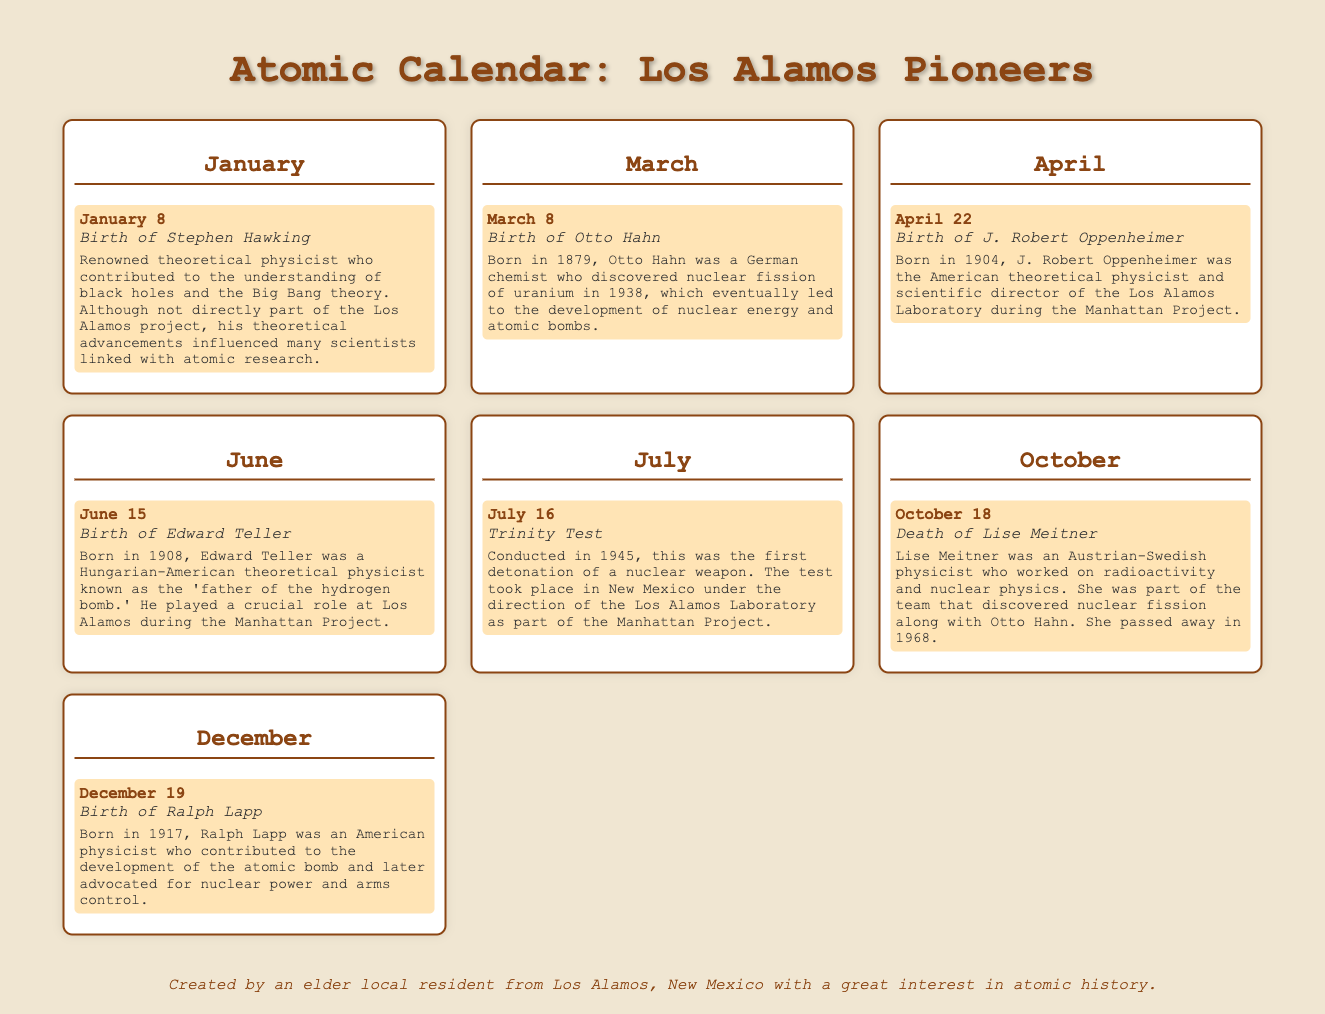what is the birth date of J. Robert Oppenheimer? The birth date of J. Robert Oppenheimer is mentioned in the April section of the document.
Answer: April 22 who is known as the 'father of the hydrogen bomb'? The title 'father of the hydrogen bomb' is given to Edward Teller in the June section of the document.
Answer: Edward Teller when was the Trinity Test conducted? The document states that the Trinity Test was conducted in July as part of the Manhattan Project.
Answer: July 16 how many events are listed in December? The December section contains only one event.
Answer: 1 which scientist contributed to the discovery of nuclear fission with Otto Hahn? The document mentions Lise Meitner as working alongside Otto Hahn on this discovery.
Answer: Lise Meitner who was the scientific director of the Los Alamos Laboratory during the Manhattan Project? The title of scientific director during the Manhattan Project is given to J. Robert Oppenheimer in the April section.
Answer: J. Robert Oppenheimer what year was Ralph Lapp born? The document specifies that Ralph Lapp was born in 1917.
Answer: 1917 which important atomic event occurred in 1945? The document states that the Trinity Test occurred in 1945.
Answer: Trinity Test 